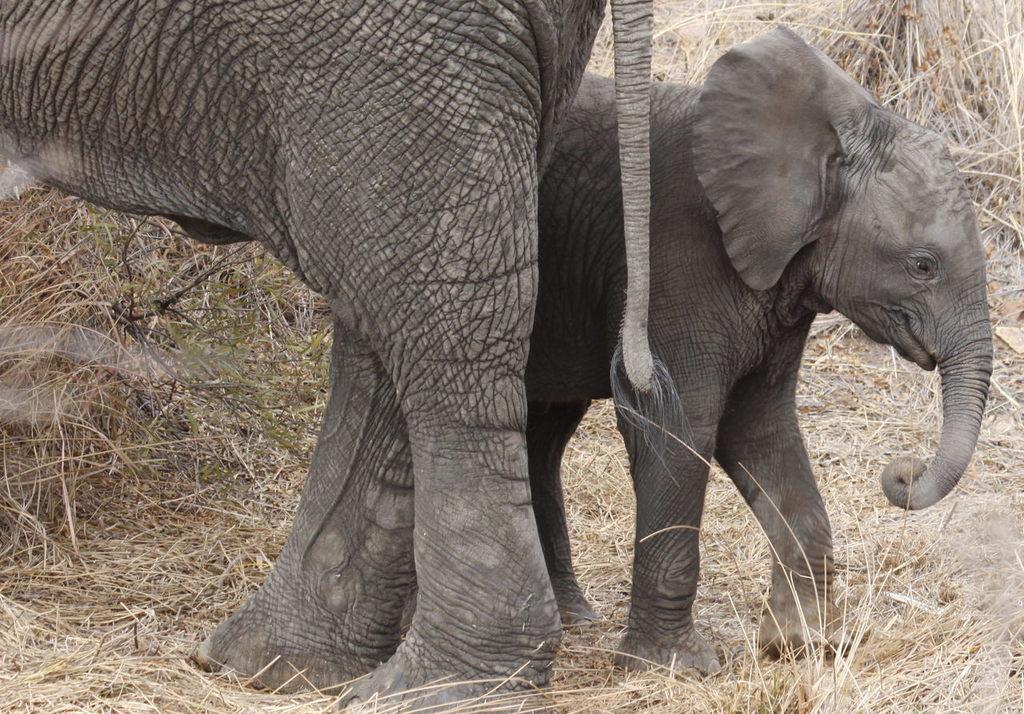Could you give a brief overview of what you see in this image? In this image we can see elephants. In the background there is grass. 